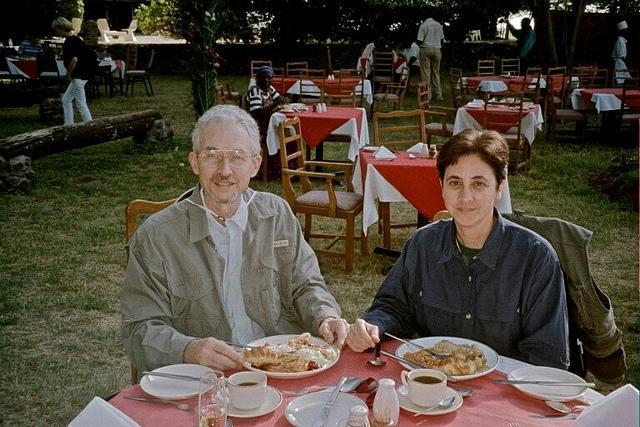How many dining tables are in the photo?
Give a very brief answer. 2. How many people are there?
Give a very brief answer. 3. How many chairs are there?
Give a very brief answer. 3. How many horses are pictured?
Give a very brief answer. 0. 